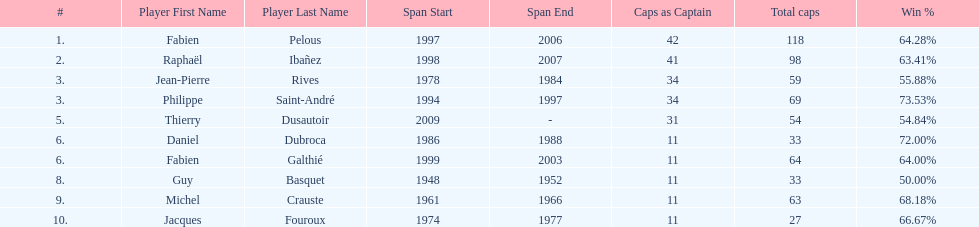How many players have spans above three years? 6. 